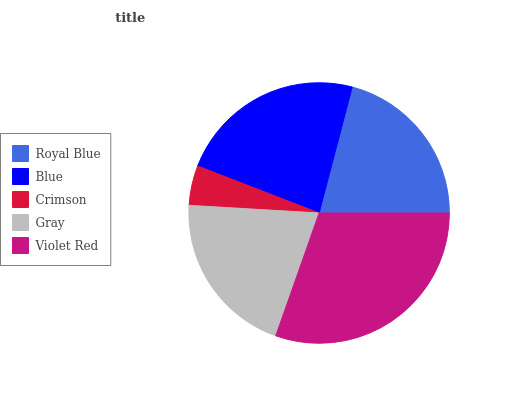Is Crimson the minimum?
Answer yes or no. Yes. Is Violet Red the maximum?
Answer yes or no. Yes. Is Blue the minimum?
Answer yes or no. No. Is Blue the maximum?
Answer yes or no. No. Is Blue greater than Royal Blue?
Answer yes or no. Yes. Is Royal Blue less than Blue?
Answer yes or no. Yes. Is Royal Blue greater than Blue?
Answer yes or no. No. Is Blue less than Royal Blue?
Answer yes or no. No. Is Royal Blue the high median?
Answer yes or no. Yes. Is Royal Blue the low median?
Answer yes or no. Yes. Is Blue the high median?
Answer yes or no. No. Is Violet Red the low median?
Answer yes or no. No. 